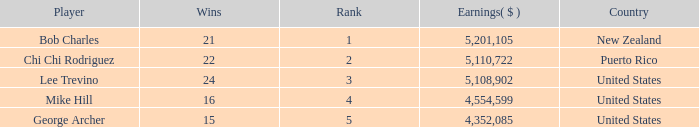On average, how many wins have a rank lower than 1? None. 